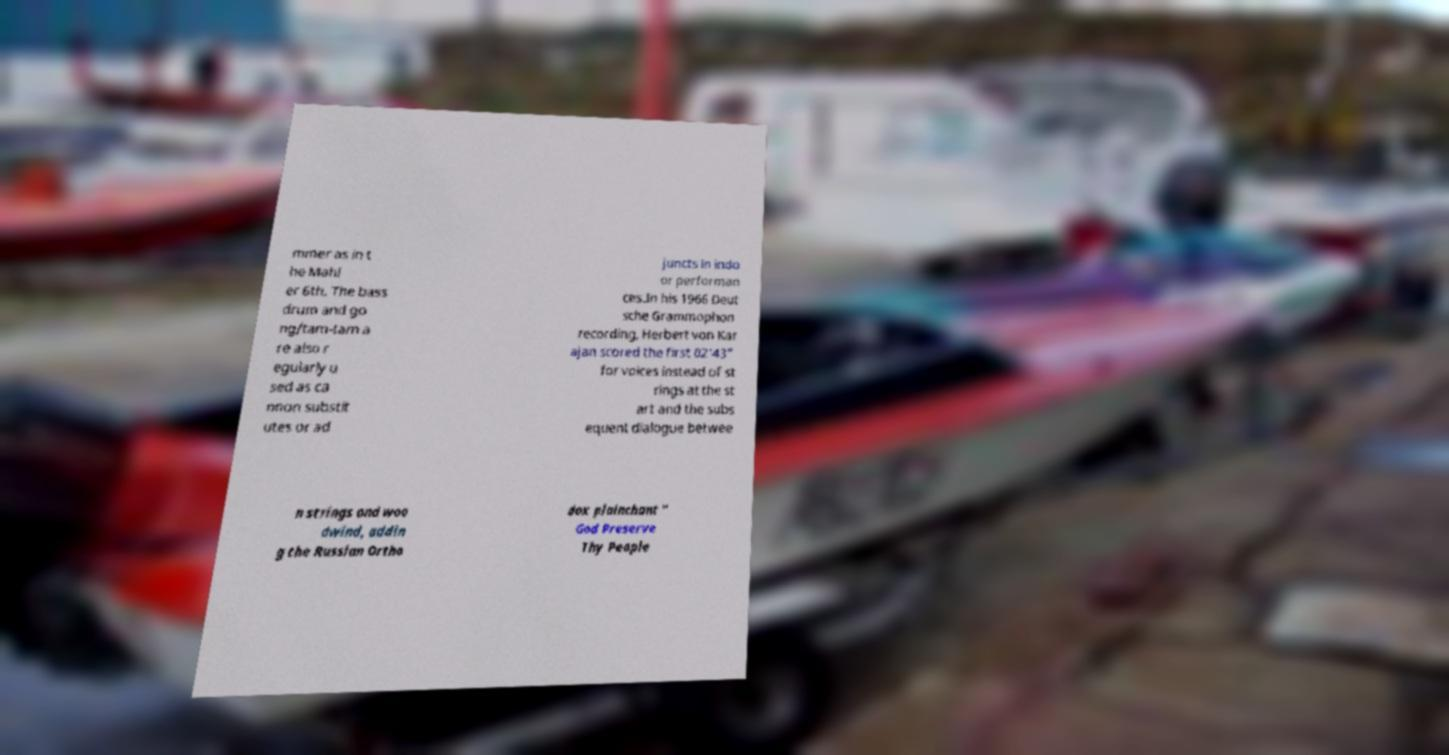Could you extract and type out the text from this image? mmer as in t he Mahl er 6th. The bass drum and go ng/tam-tam a re also r egularly u sed as ca nnon substit utes or ad juncts in indo or performan ces.In his 1966 Deut sche Grammophon recording, Herbert von Kar ajan scored the first 02'43" for voices instead of st rings at the st art and the subs equent dialogue betwee n strings and woo dwind, addin g the Russian Ortho dox plainchant " God Preserve Thy People 